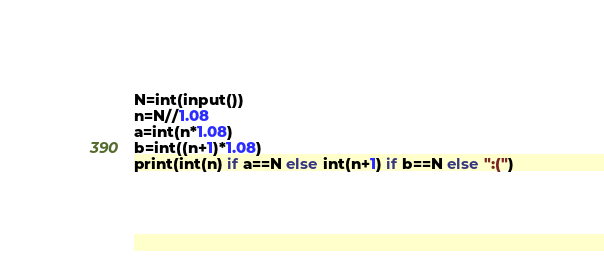Convert code to text. <code><loc_0><loc_0><loc_500><loc_500><_Python_>N=int(input())
n=N//1.08
a=int(n*1.08)
b=int((n+1)*1.08)
print(int(n) if a==N else int(n+1) if b==N else ":(")</code> 